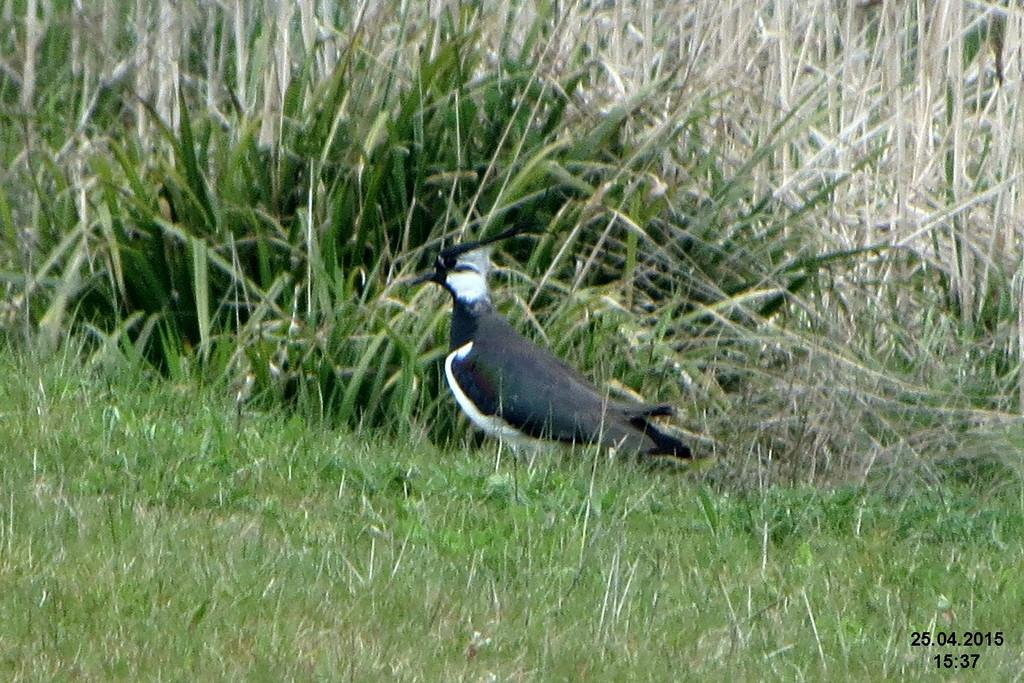What type of animal is in the image? There is a bird in the image. What color is the bird? The bird is black in color. What is at the bottom of the image? There is green grass at the bottom of the image. What can be seen in the background of the image? There are plants in the background of the image. Can you hear the bird cry in the image? There is no sound in the image, so it is not possible to hear the bird cry. 